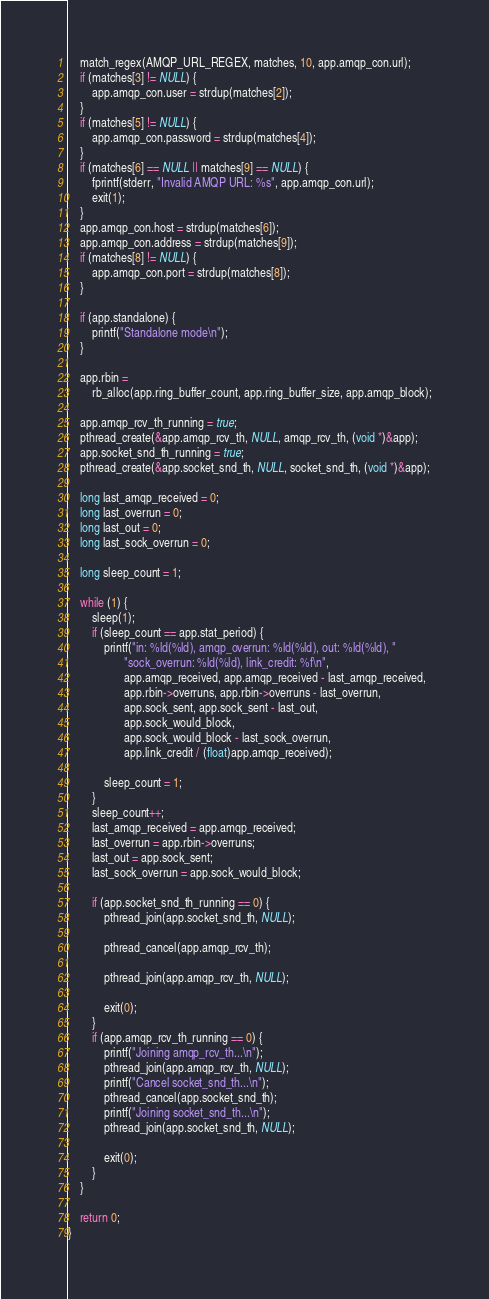<code> <loc_0><loc_0><loc_500><loc_500><_C_>    match_regex(AMQP_URL_REGEX, matches, 10, app.amqp_con.url);
    if (matches[3] != NULL) {
        app.amqp_con.user = strdup(matches[2]);
    }
    if (matches[5] != NULL) {
        app.amqp_con.password = strdup(matches[4]);
    }
    if (matches[6] == NULL || matches[9] == NULL) {
        fprintf(stderr, "Invalid AMQP URL: %s", app.amqp_con.url);
        exit(1);
    }
    app.amqp_con.host = strdup(matches[6]);
    app.amqp_con.address = strdup(matches[9]);
    if (matches[8] != NULL) {
        app.amqp_con.port = strdup(matches[8]);
    }

    if (app.standalone) {
        printf("Standalone mode\n");
    }

    app.rbin =
        rb_alloc(app.ring_buffer_count, app.ring_buffer_size, app.amqp_block);

    app.amqp_rcv_th_running = true;
    pthread_create(&app.amqp_rcv_th, NULL, amqp_rcv_th, (void *)&app);
    app.socket_snd_th_running = true;
    pthread_create(&app.socket_snd_th, NULL, socket_snd_th, (void *)&app);

    long last_amqp_received = 0;
    long last_overrun = 0;
    long last_out = 0;
    long last_sock_overrun = 0;

    long sleep_count = 1;

    while (1) {
        sleep(1);
        if (sleep_count == app.stat_period) {
            printf("in: %ld(%ld), amqp_overrun: %ld(%ld), out: %ld(%ld), "
                   "sock_overrun: %ld(%ld), link_credit: %f\n",
                   app.amqp_received, app.amqp_received - last_amqp_received,
                   app.rbin->overruns, app.rbin->overruns - last_overrun,
                   app.sock_sent, app.sock_sent - last_out,
                   app.sock_would_block,
                   app.sock_would_block - last_sock_overrun,
                   app.link_credit / (float)app.amqp_received);

            sleep_count = 1;
        }
        sleep_count++;
        last_amqp_received = app.amqp_received;
        last_overrun = app.rbin->overruns;
        last_out = app.sock_sent;
        last_sock_overrun = app.sock_would_block;

        if (app.socket_snd_th_running == 0) {
            pthread_join(app.socket_snd_th, NULL);

            pthread_cancel(app.amqp_rcv_th);

            pthread_join(app.amqp_rcv_th, NULL);

            exit(0);
        }
        if (app.amqp_rcv_th_running == 0) {
            printf("Joining amqp_rcv_th...\n");
            pthread_join(app.amqp_rcv_th, NULL);
            printf("Cancel socket_snd_th...\n");
            pthread_cancel(app.socket_snd_th);
            printf("Joining socket_snd_th...\n");
            pthread_join(app.socket_snd_th, NULL);

            exit(0);
        }
    }

    return 0;
}
</code> 